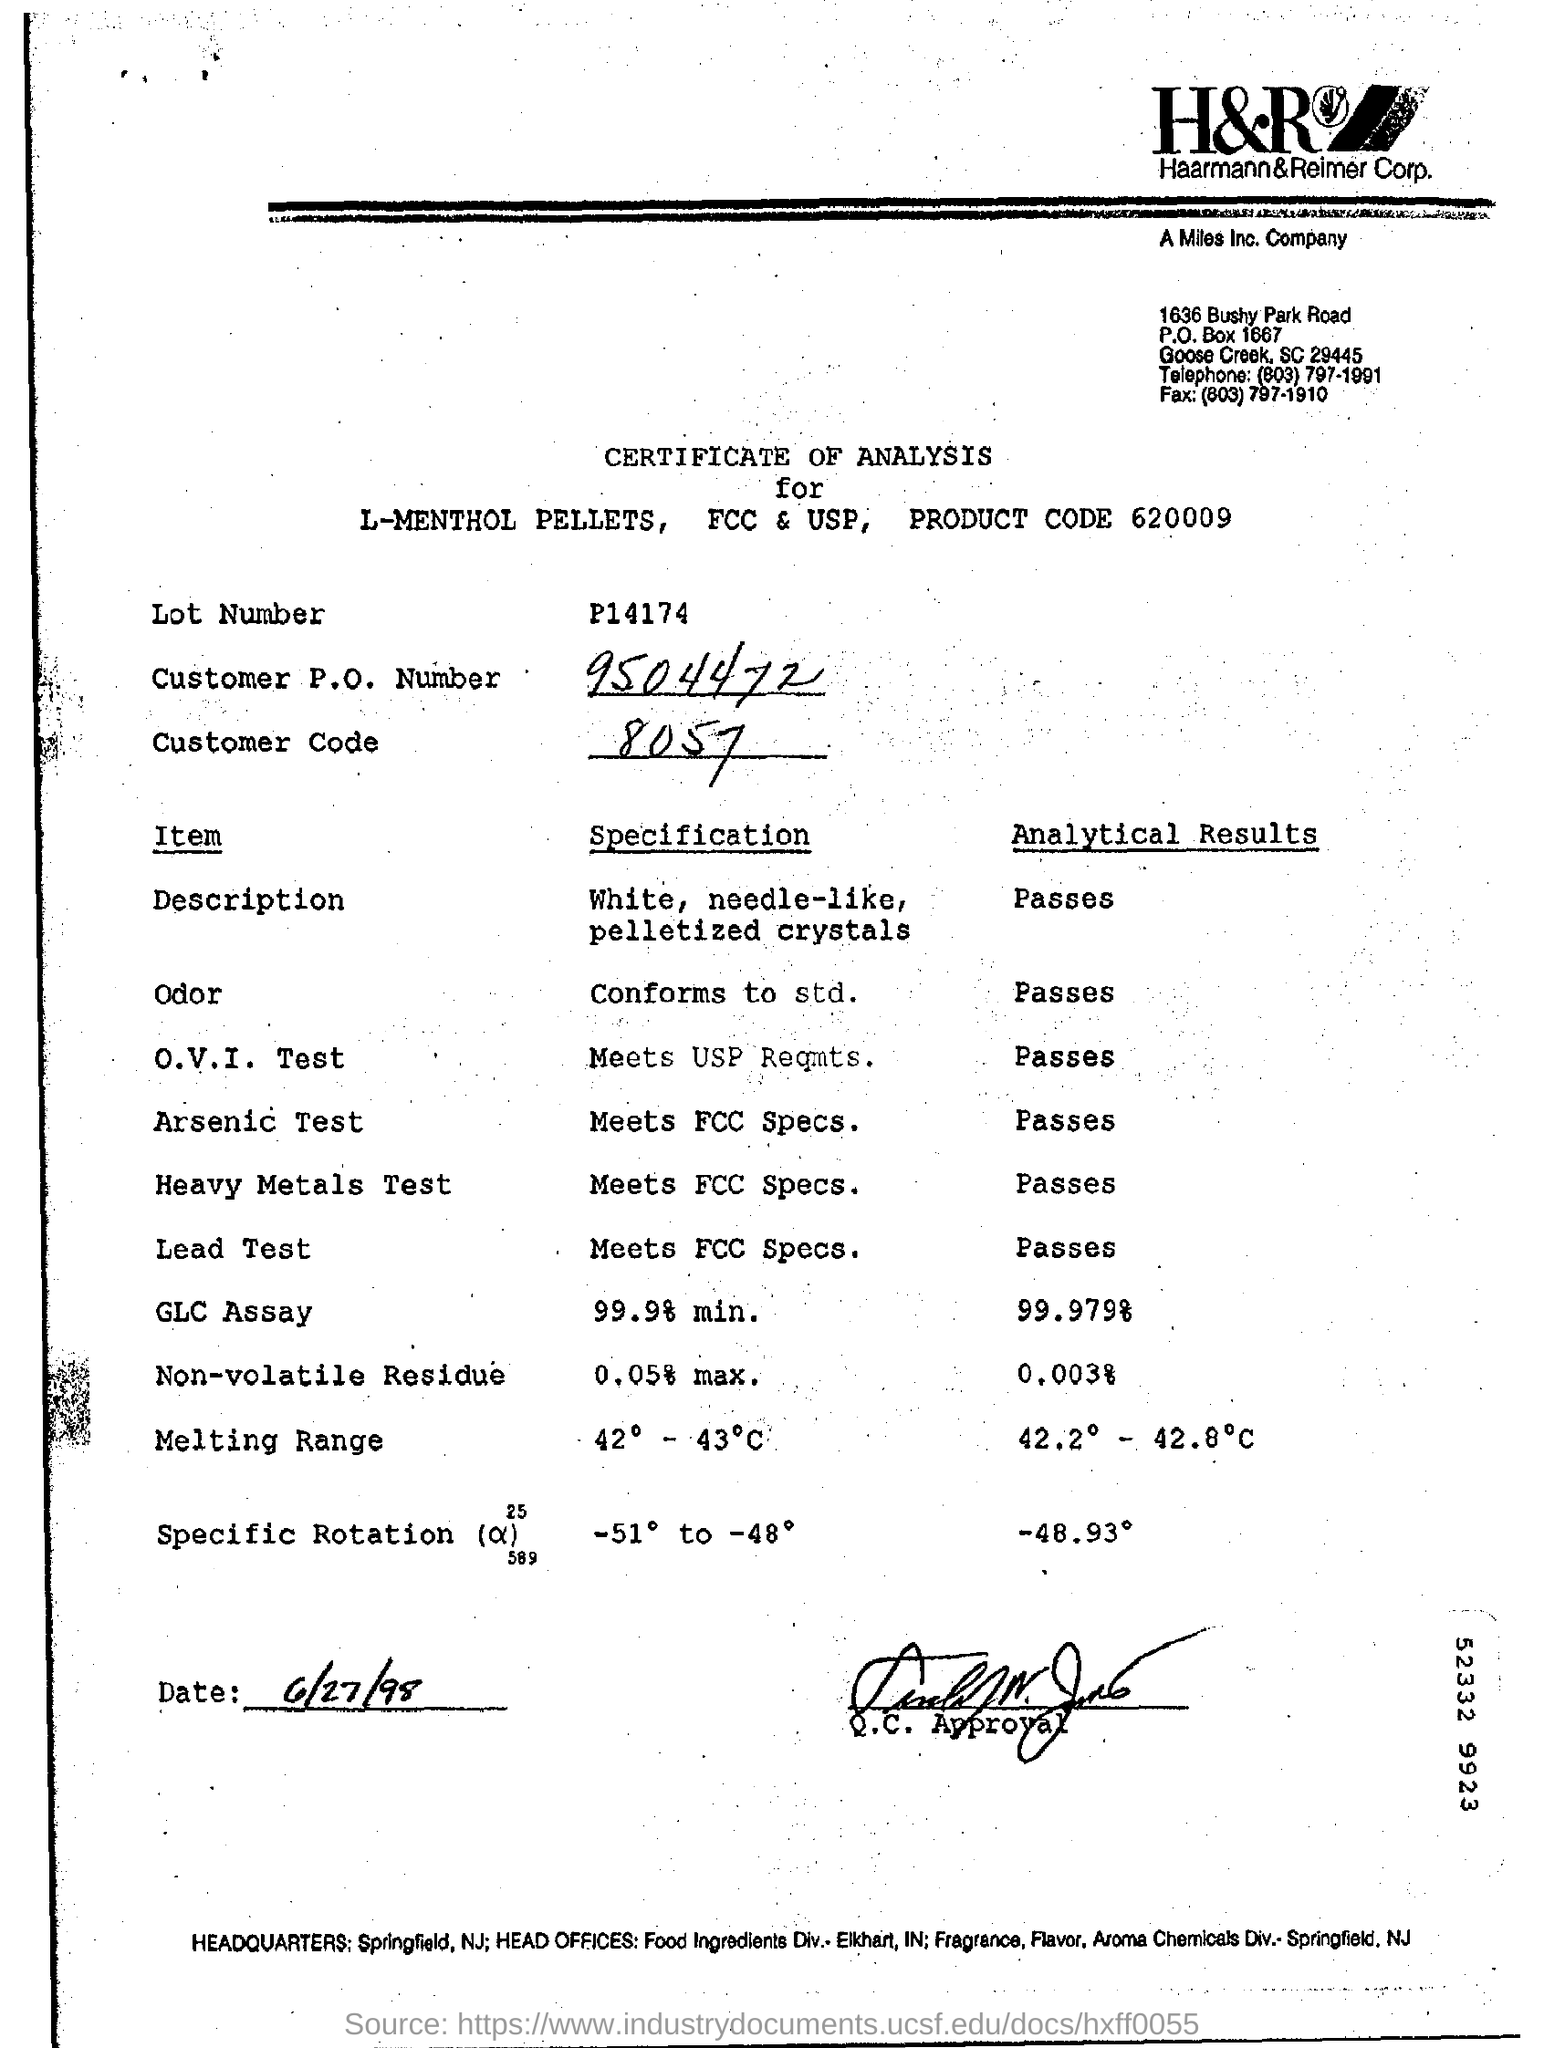What is customer P.O number?
Ensure brevity in your answer.  9504472. What is customer code?
Your response must be concise. 8057. What is date?
Make the answer very short. 6/27/98. 